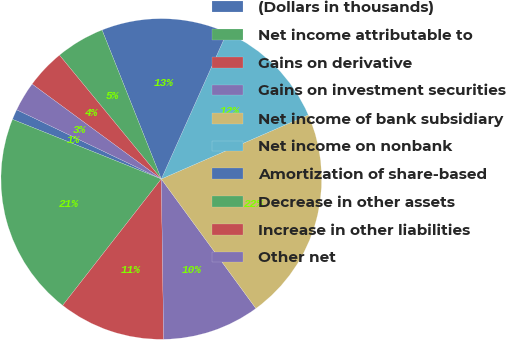Convert chart to OTSL. <chart><loc_0><loc_0><loc_500><loc_500><pie_chart><fcel>(Dollars in thousands)<fcel>Net income attributable to<fcel>Gains on derivative<fcel>Gains on investment securities<fcel>Net income of bank subsidiary<fcel>Net income on nonbank<fcel>Amortization of share-based<fcel>Decrease in other assets<fcel>Increase in other liabilities<fcel>Other net<nl><fcel>1.04%<fcel>20.52%<fcel>10.78%<fcel>9.81%<fcel>21.5%<fcel>11.75%<fcel>12.73%<fcel>4.93%<fcel>3.96%<fcel>2.98%<nl></chart> 